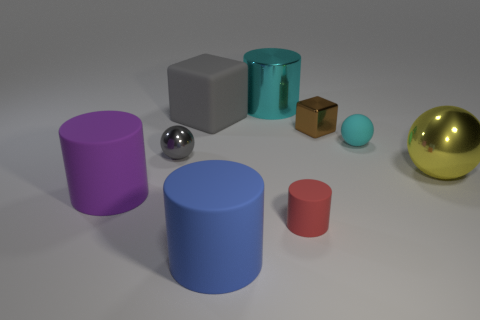Add 1 cyan metal objects. How many objects exist? 10 Subtract all balls. How many objects are left? 6 Add 6 big yellow spheres. How many big yellow spheres exist? 7 Subtract 0 red spheres. How many objects are left? 9 Subtract all small metal things. Subtract all purple matte cylinders. How many objects are left? 6 Add 9 matte cubes. How many matte cubes are left? 10 